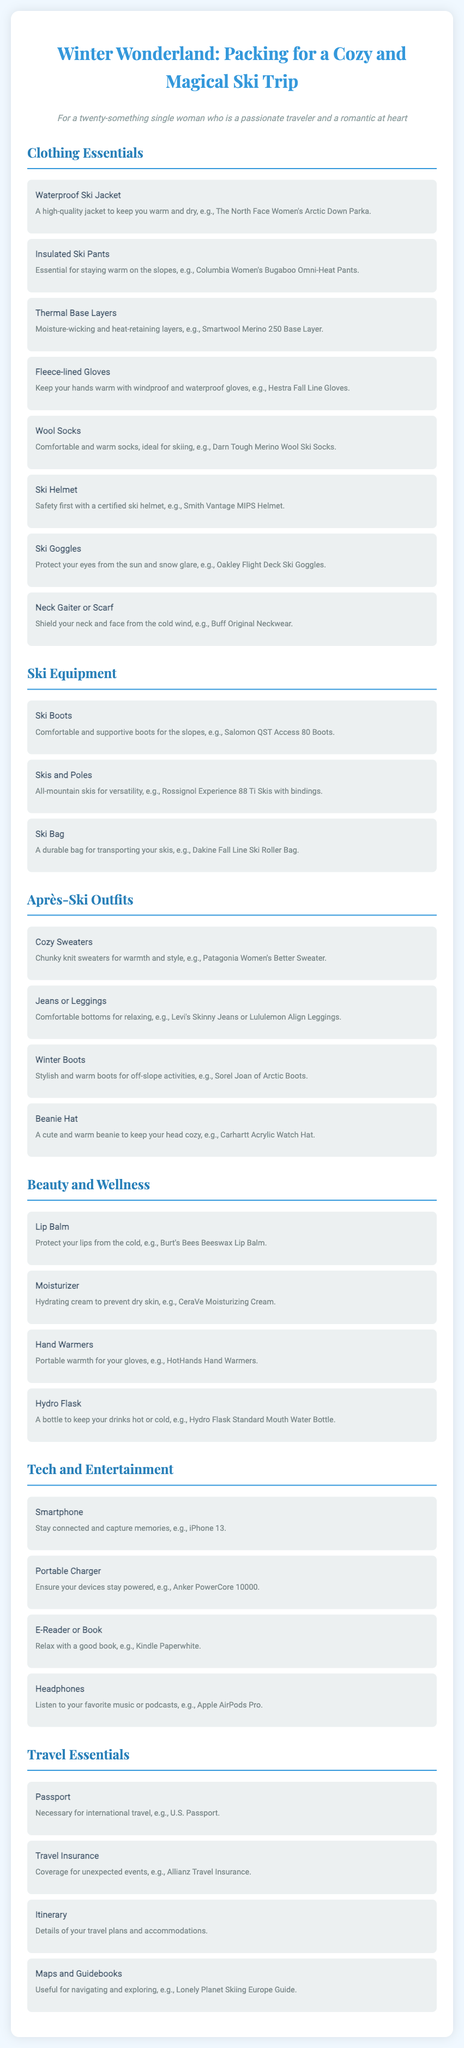What is the title of the document? The title is the main heading that describes the content, which is about packing for a ski trip.
Answer: Winter Wonderland: Packing for a Cozy and Magical Ski Trip How many categories of items are listed? The document contains multiple sections, each dedicated to different types of items needed for the trip.
Answer: Six What type of gloves are recommended? The document specifies the type of gloves that will keep hands warm and are suitable for skiing.
Answer: Fleece-lined Gloves Which waterproof jacket is suggested? The document provides a specific brand and model as an example for waterproof jackets to use on the trip.
Answer: The North Face Women's Arctic Down Parka What is an example of an après-ski outfit? The document lists items that can be worn after skiing to maintain comfort and style.
Answer: Cozy Sweaters What is one beauty item to pack? The beauty section suggests products that will help maintain skin and lip hydration in cold weather.
Answer: Lip Balm How many different ski equipment items are listed? The document includes a specific number of items needed for skiing and their descriptions.
Answer: Three What is the recommended ski helmet? The document mentions a specific ski helmet brand and model for safety while skiing.
Answer: Smith Vantage MIPS Helmet Is travel insurance included in the packing list? The travel essentials section indicates whether insurance is suggested for travelers to cover unexpected events.
Answer: Yes 